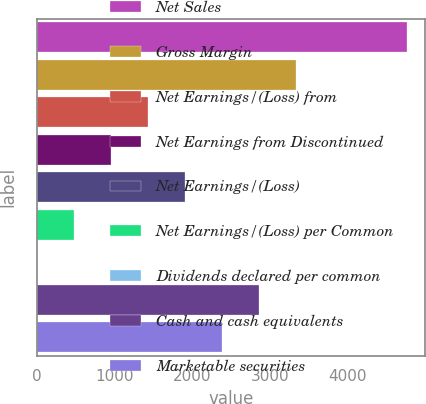<chart> <loc_0><loc_0><loc_500><loc_500><bar_chart><fcel>Net Sales<fcel>Gross Margin<fcel>Net Earnings/(Loss) from<fcel>Net Earnings from Discontinued<fcel>Net Earnings/(Loss)<fcel>Net Earnings/(Loss) per Common<fcel>Dividends declared per common<fcel>Cash and cash equivalents<fcel>Marketable securities<nl><fcel>4757<fcel>3329.97<fcel>1427.29<fcel>951.62<fcel>1902.96<fcel>475.95<fcel>0.28<fcel>2854.3<fcel>2378.63<nl></chart> 